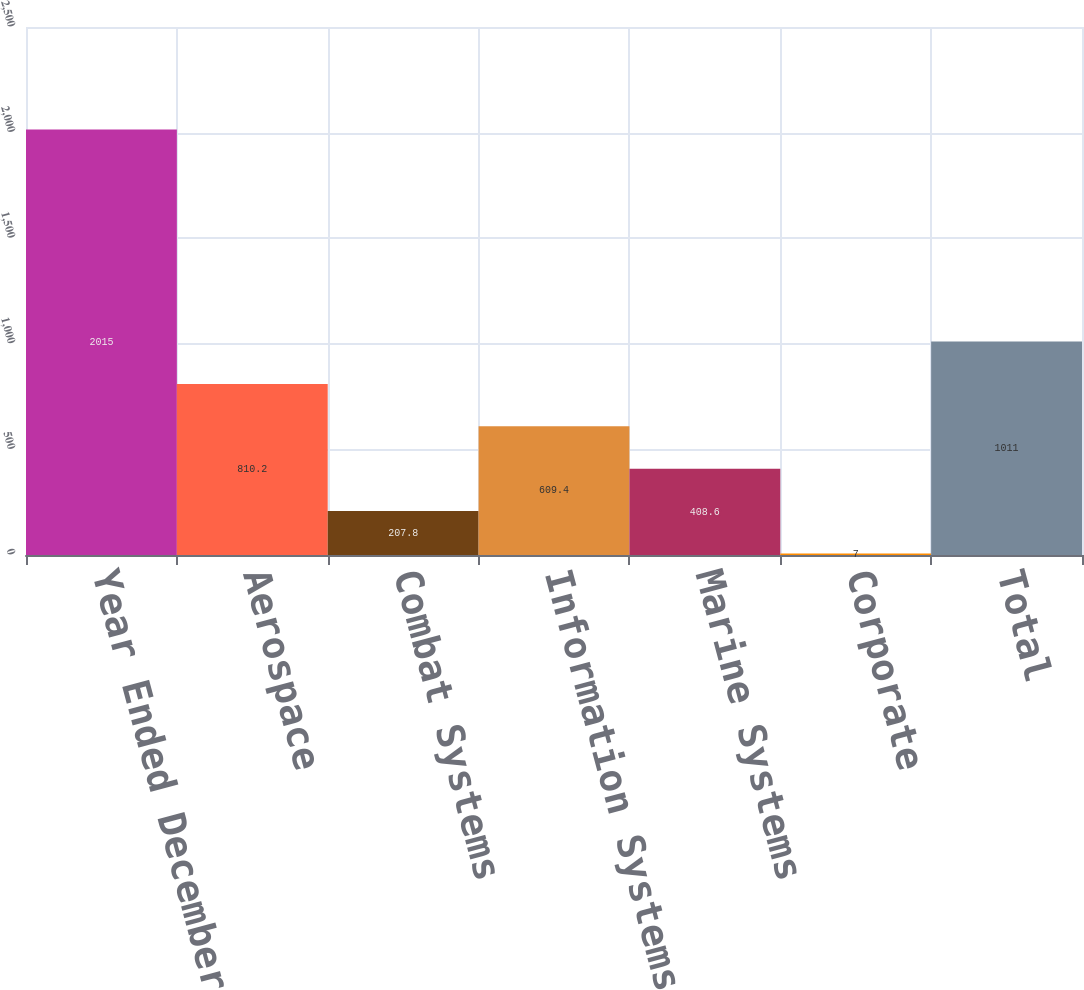Convert chart. <chart><loc_0><loc_0><loc_500><loc_500><bar_chart><fcel>Year Ended December 31<fcel>Aerospace<fcel>Combat Systems<fcel>Information Systems and<fcel>Marine Systems<fcel>Corporate<fcel>Total<nl><fcel>2015<fcel>810.2<fcel>207.8<fcel>609.4<fcel>408.6<fcel>7<fcel>1011<nl></chart> 